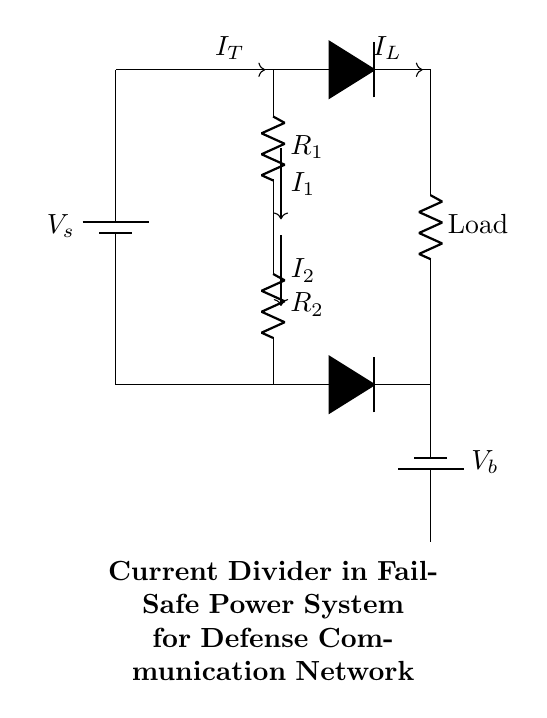What is the supply voltage in this circuit? The supply voltage is indicated as V_s, which is connected to the main supply. It is labeled in the circuit diagram and represents the voltage feeding the current divider.
Answer: V_s What are the values of resistors R_1 and R_2? The resistor values are not specified in the circuit diagram, as they are labeled simply as R_1 and R_2. Their specific resistance values would need to be provided separately, but they are both essential for current division.
Answer: R_1 and R_2 How many branches are there in the current divider? The current divider has three branches: one for R_1, one for R_2, and one for the load. Each of these branches carries a portion of the total current supplied.
Answer: Three What happens to the load current when R_2 increases? When R_2 increases, the voltage drop across it also increases, which causes the load current, I_L, to decrease due to the current division principle, as the total current splits inversely proportional to the resistances.
Answer: Decreases Which component acts as a backup power source? The backup power source is the battery labeled V_b located at the bottom of the circuit diagram. It is meant to ensure that power is available in case the main supply is insufficient.
Answer: V_b How do the diodes contribute to the fail-safe design? The diodes allow current to flow in one direction, ensuring that if the main supply fails, the backup battery can supply power without feeding back into the main circuit, creating a fail-safe mechanism in the design.
Answer: Prevent feedback What is the significance of current I_T in this circuit? The current I_T represents the total current supplied to the circuit from the main voltage source and is critical for understanding how the total current is divided between R_1, R_2, and the load.
Answer: Total current 